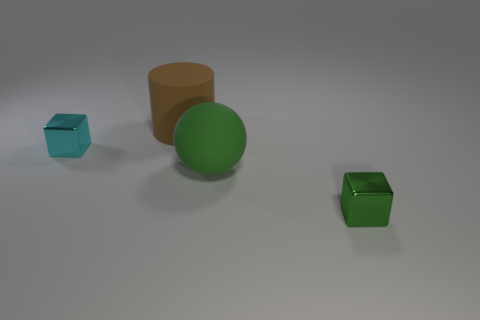Do the objects share any similarities? Yes, despite their different shapes and sizes, two objects share the color green, while the overall matte texture is a common characteristic among all objects. 